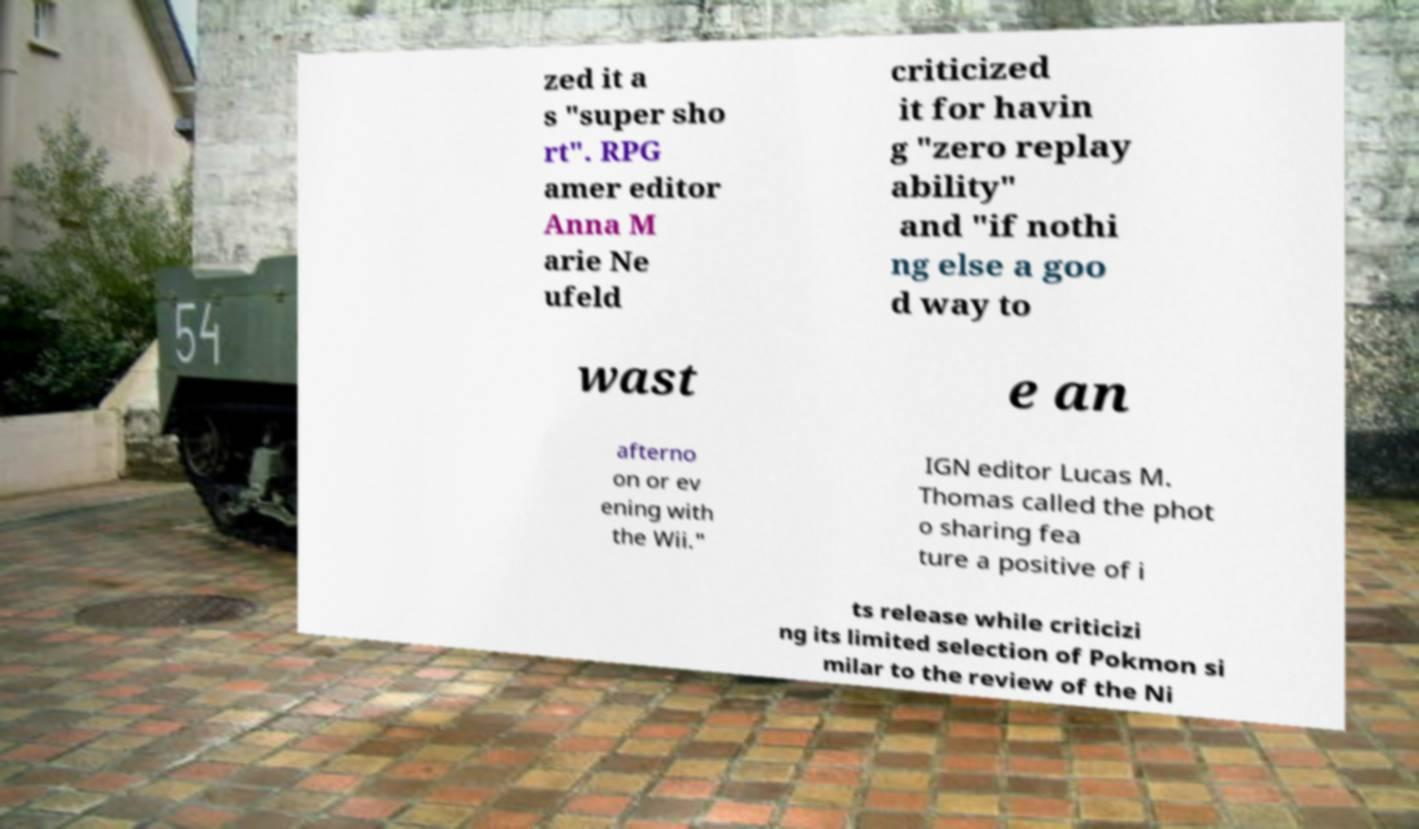Please identify and transcribe the text found in this image. zed it a s "super sho rt". RPG amer editor Anna M arie Ne ufeld criticized it for havin g "zero replay ability" and "if nothi ng else a goo d way to wast e an afterno on or ev ening with the Wii." IGN editor Lucas M. Thomas called the phot o sharing fea ture a positive of i ts release while criticizi ng its limited selection of Pokmon si milar to the review of the Ni 